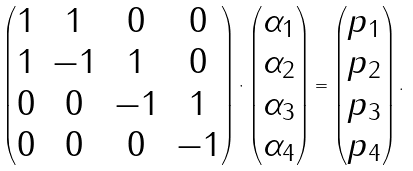Convert formula to latex. <formula><loc_0><loc_0><loc_500><loc_500>\begin{pmatrix} 1 & 1 & 0 & 0 \\ 1 & - 1 & 1 & 0 \\ 0 & 0 & - 1 & 1 \\ 0 & 0 & 0 & - 1 \\ \end{pmatrix} \cdot \begin{pmatrix} \alpha _ { 1 } \\ \alpha _ { 2 } \\ \alpha _ { 3 } \\ \alpha _ { 4 } \\ \end{pmatrix} = \begin{pmatrix} p _ { 1 } \\ p _ { 2 } \\ p _ { 3 } \\ p _ { 4 } \\ \end{pmatrix} .</formula> 